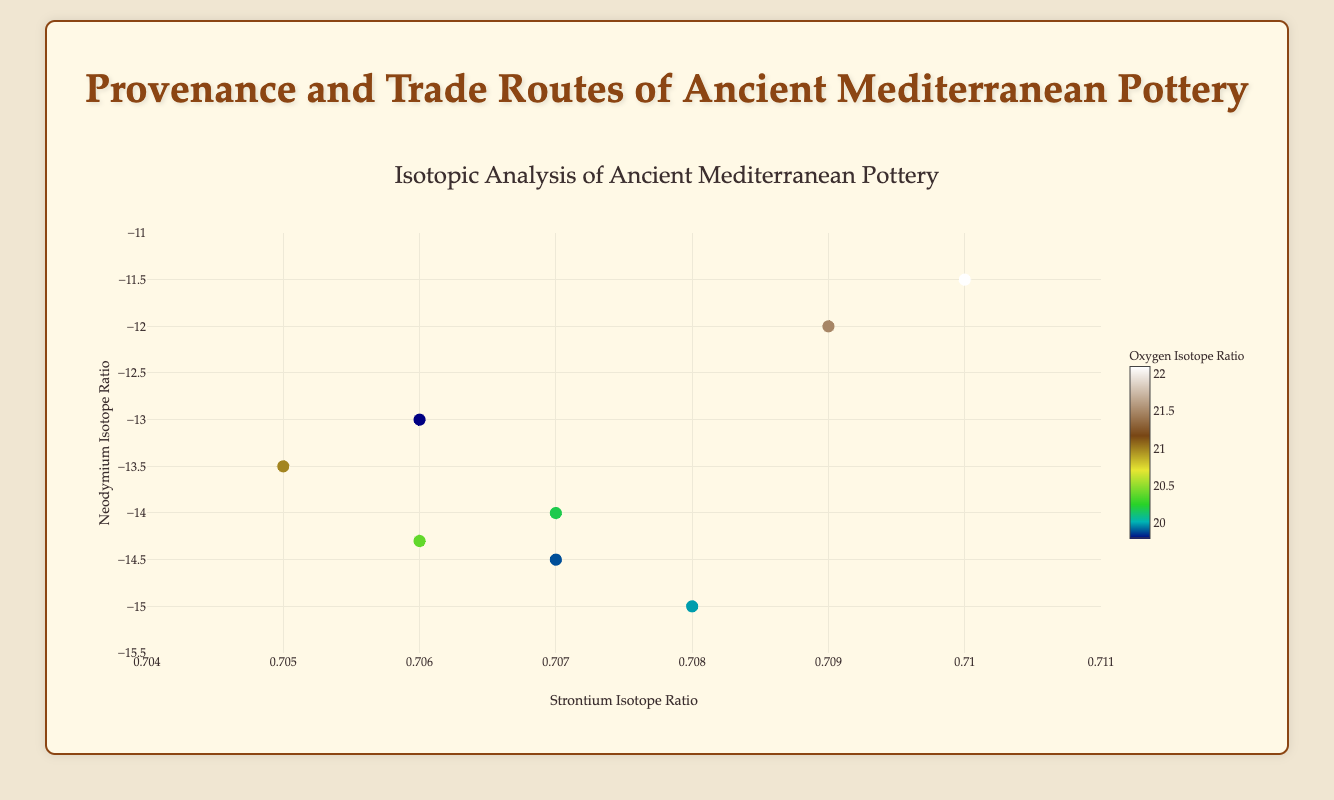How many artifacts are displayed in the scatter plot? Count the number of markers (data points) in the scatter plot. Each marker represents an artifact.
Answer: 8 What is the title of the scatter plot? Look at the title text displayed at the top of the plot. It is clearly written and usually larger in size.
Answer: Isotopic Analysis of Ancient Mediterranean Pottery Which artifact has the highest Strontium Isotope Ratio? Find the marker with the highest position on the x-axis (Strontium Isotope Ratio) and check the hovertext for the Artifact_ID.
Answer: BM_Pot_007 Comparing artifacts BM_Pot_004 and BM_Pot_006, which has a lower Neodymium Isotope Ratio? Locate both artifacts by their IDs using hovertext and compare their positions on the y-axis (Neodymium Isotope Ratio). BM_Pot_004 has a y-value of -15.0, which is lower than BM_Pot_006's y-value of -14.5.
Answer: BM_Pot_004 What is the average Oxygen Isotope Ratio of all artifacts? Sum up the Oxygen Isotope Ratios of all artifacts: (20.2 + 21.5 + 19.8 + 20.0 + 21.0 + 19.9 + 22.1 + 20.4) = 165.9, then divide by the number of artifacts (8).
Answer: 20.7375 Which artifact has its origin at "Rome"? Use hovertext to check the Origin of each artifact and identify the artifact with Rome as its origin.
Answer: BM_Pot_005 Is there any artifact with a Neodymium Isotope Ratio of -13.0? If yes, which one? Look for a marker located at y = -13.0 on the y-axis and check its hovertext to find the Artifact_ID.
Answer: BM_Pot_003 Which artifact has the brightest color, indicating the highest Oxygen Isotope Ratio? Observe the color scale (Earth colorscale) and find the marker with the brightest color, then check its hovertext.
Answer: BM_Pot_007 How many artifacts have a Strontium Isotope Ratio greater than 0.708? Count the markers that lie beyond the x = 0.708 mark on the x-axis.
Answer: 3 Comparing BM_Pot_001 and BM_Pot_002, which has a higher Oxygen Isotope Ratio? Hover over the markers of BM_Pot_001 and BM_Pot_002 and compare their Oxygen Isotope Ratios. BM_Pot_001 has a ratio of 20.2, and BM_Pot_002 has a ratio of 21.5.
Answer: BM_Pot_002 